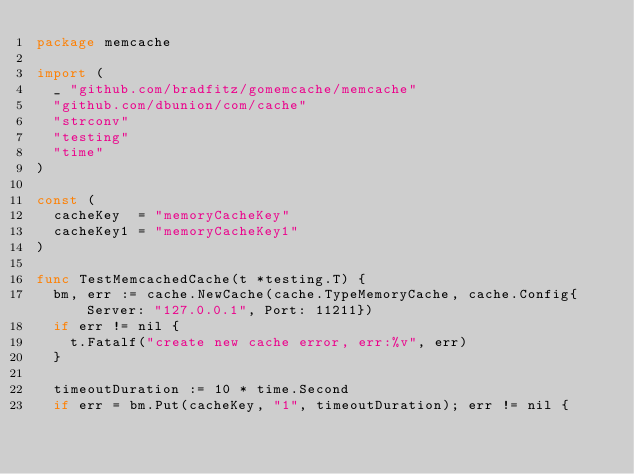Convert code to text. <code><loc_0><loc_0><loc_500><loc_500><_Go_>package memcache

import (
	_ "github.com/bradfitz/gomemcache/memcache"
	"github.com/dbunion/com/cache"
	"strconv"
	"testing"
	"time"
)

const (
	cacheKey  = "memoryCacheKey"
	cacheKey1 = "memoryCacheKey1"
)

func TestMemcachedCache(t *testing.T) {
	bm, err := cache.NewCache(cache.TypeMemoryCache, cache.Config{Server: "127.0.0.1", Port: 11211})
	if err != nil {
		t.Fatalf("create new cache error, err:%v", err)
	}

	timeoutDuration := 10 * time.Second
	if err = bm.Put(cacheKey, "1", timeoutDuration); err != nil {</code> 